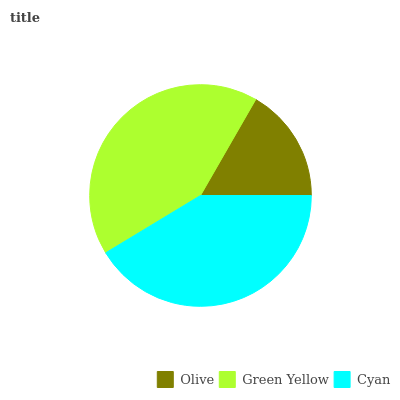Is Olive the minimum?
Answer yes or no. Yes. Is Green Yellow the maximum?
Answer yes or no. Yes. Is Cyan the minimum?
Answer yes or no. No. Is Cyan the maximum?
Answer yes or no. No. Is Green Yellow greater than Cyan?
Answer yes or no. Yes. Is Cyan less than Green Yellow?
Answer yes or no. Yes. Is Cyan greater than Green Yellow?
Answer yes or no. No. Is Green Yellow less than Cyan?
Answer yes or no. No. Is Cyan the high median?
Answer yes or no. Yes. Is Cyan the low median?
Answer yes or no. Yes. Is Green Yellow the high median?
Answer yes or no. No. Is Olive the low median?
Answer yes or no. No. 